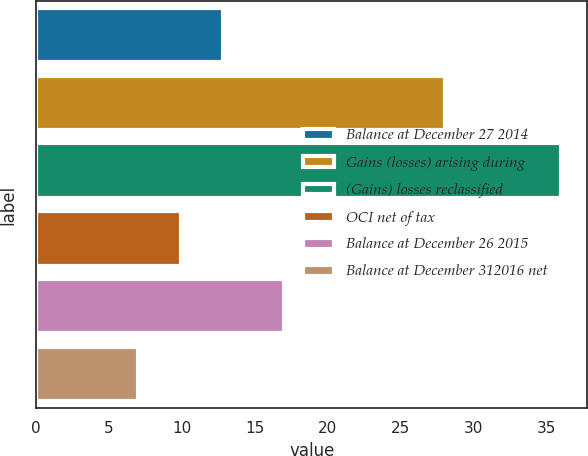Convert chart. <chart><loc_0><loc_0><loc_500><loc_500><bar_chart><fcel>Balance at December 27 2014<fcel>Gains (losses) arising during<fcel>(Gains) losses reclassified<fcel>OCI net of tax<fcel>Balance at December 26 2015<fcel>Balance at December 312016 net<nl><fcel>12.8<fcel>28<fcel>36<fcel>9.9<fcel>17<fcel>7<nl></chart> 